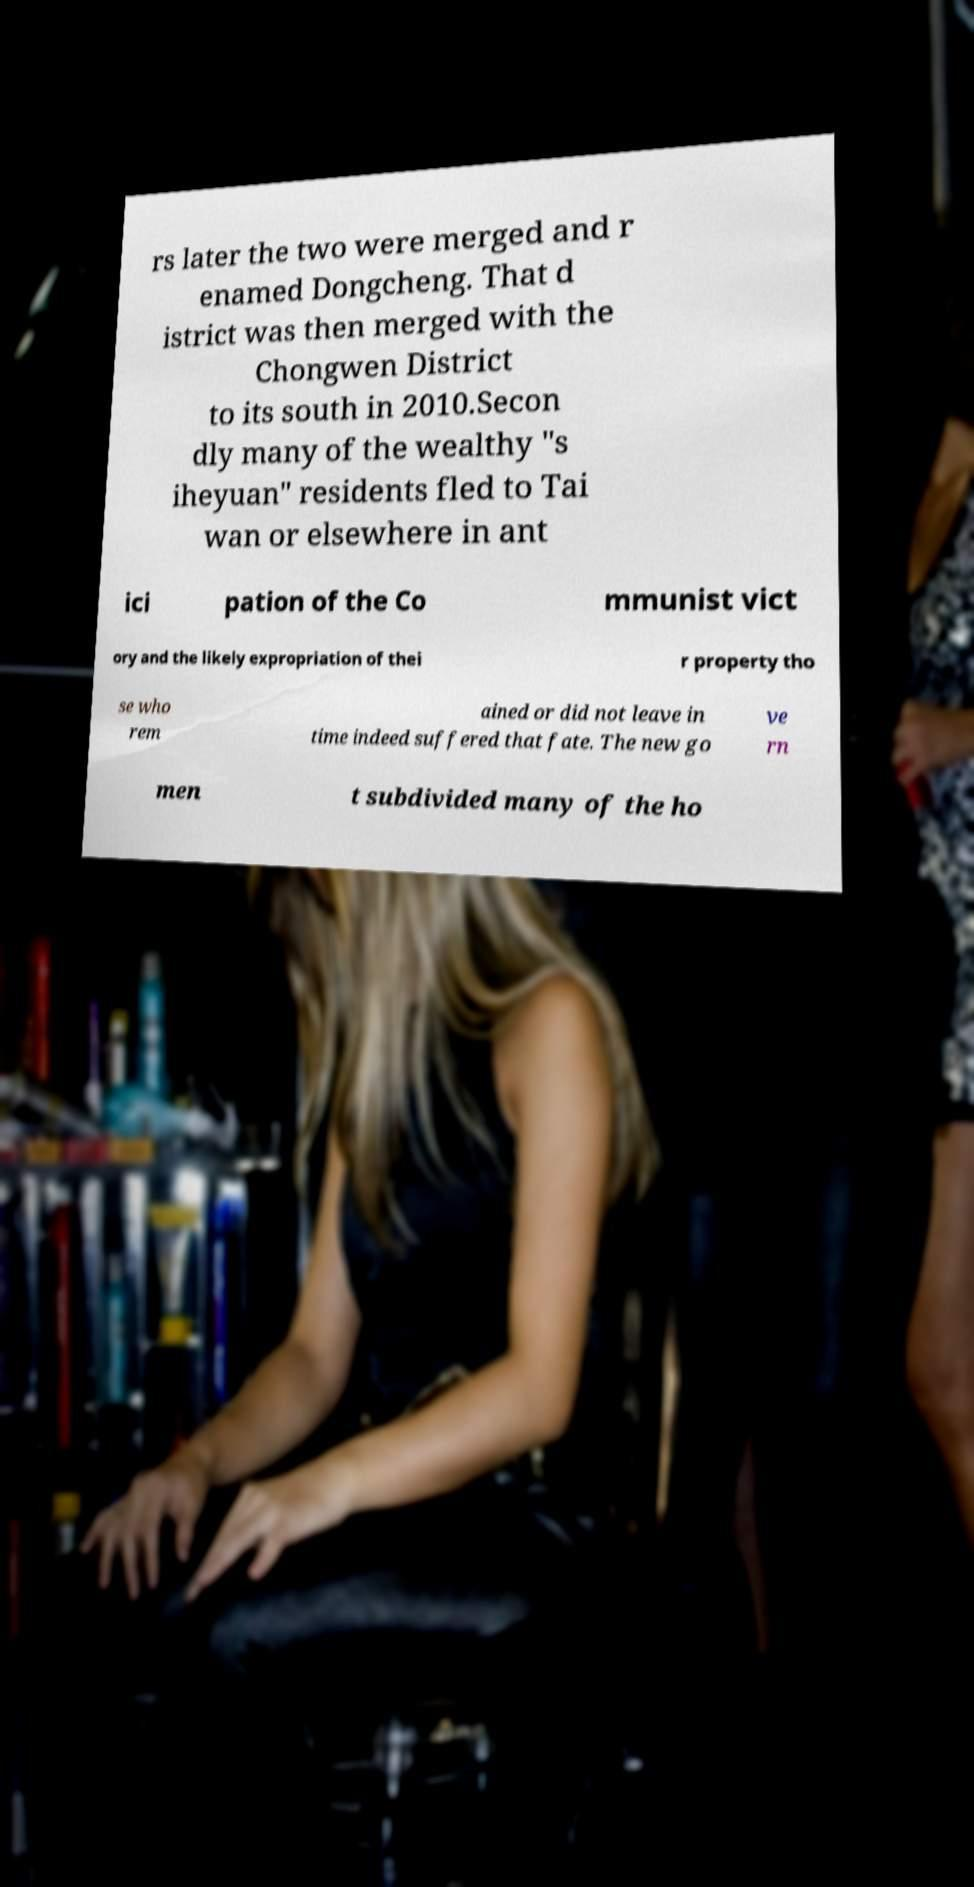There's text embedded in this image that I need extracted. Can you transcribe it verbatim? rs later the two were merged and r enamed Dongcheng. That d istrict was then merged with the Chongwen District to its south in 2010.Secon dly many of the wealthy "s iheyuan" residents fled to Tai wan or elsewhere in ant ici pation of the Co mmunist vict ory and the likely expropriation of thei r property tho se who rem ained or did not leave in time indeed suffered that fate. The new go ve rn men t subdivided many of the ho 